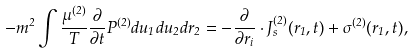<formula> <loc_0><loc_0><loc_500><loc_500>- m ^ { 2 } \int \frac { \mu ^ { ( 2 ) } } { T } \frac { \partial } { \partial t } P ^ { ( 2 ) } d u _ { 1 } d u _ { 2 } d r _ { 2 } = - \frac { \partial } { \partial r _ { i } } \cdot J _ { s } ^ { ( 2 ) } ( r _ { 1 } , t ) + \sigma ^ { ( 2 ) } ( r _ { 1 } , t ) ,</formula> 